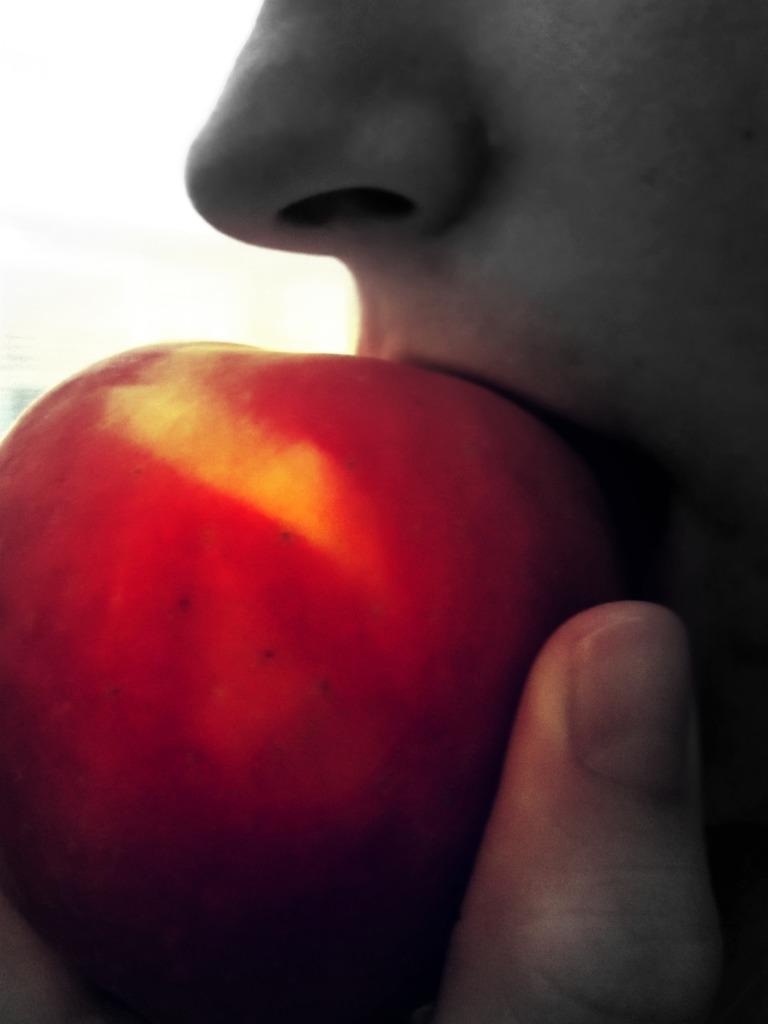Can you describe this image briefly? In this image I can see a person eating apple. 